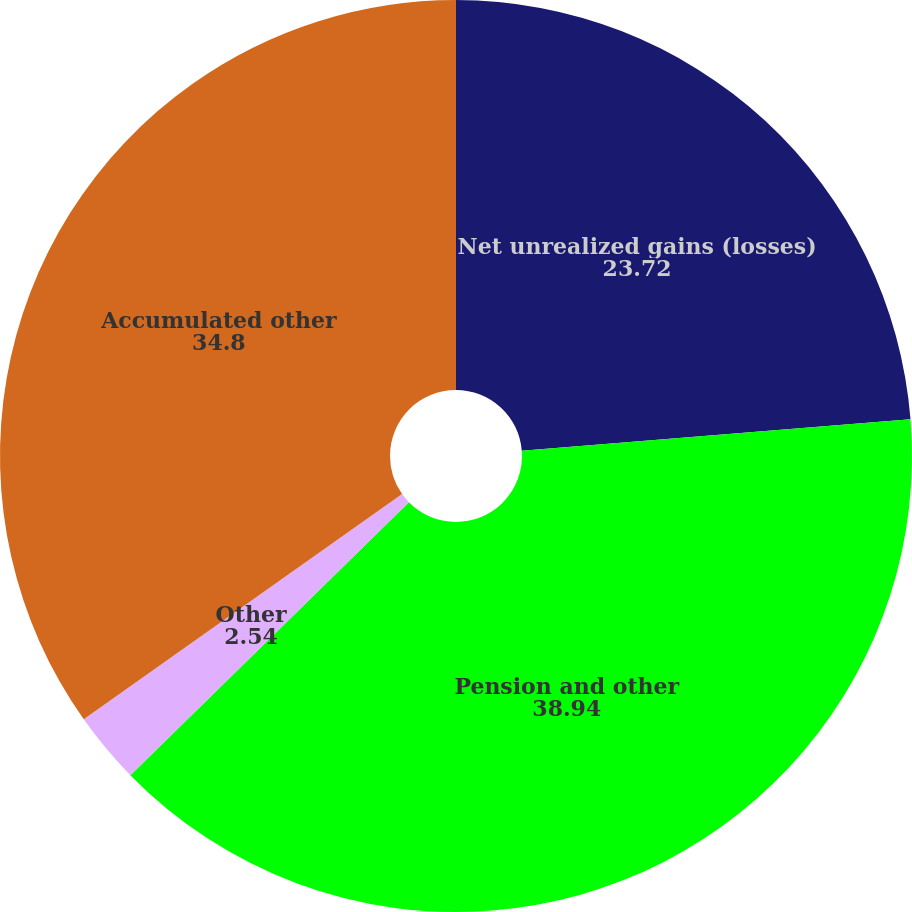Convert chart. <chart><loc_0><loc_0><loc_500><loc_500><pie_chart><fcel>Net unrealized gains (losses)<fcel>Pension and other<fcel>Other<fcel>Accumulated other<nl><fcel>23.72%<fcel>38.94%<fcel>2.54%<fcel>34.8%<nl></chart> 